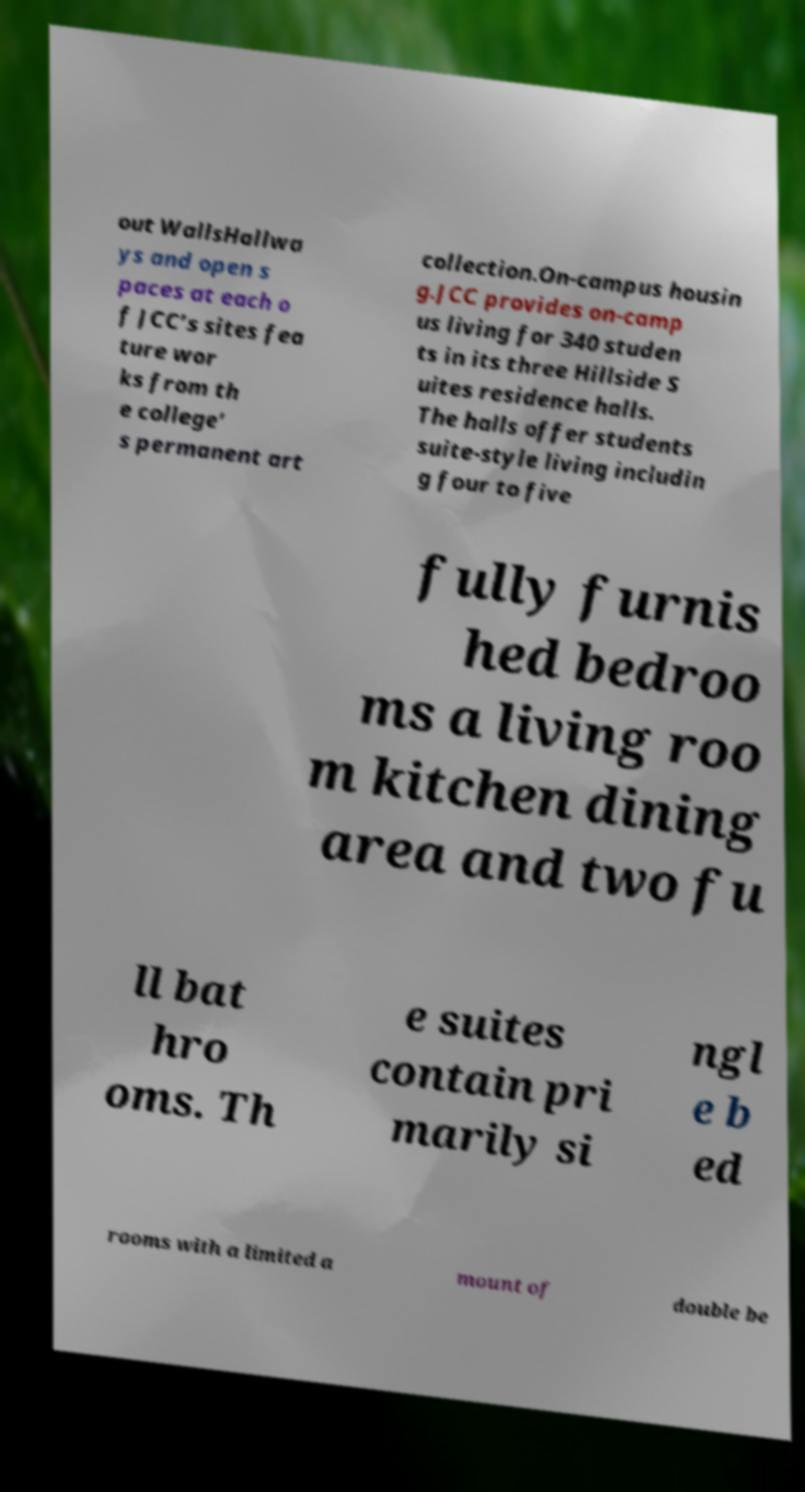Please identify and transcribe the text found in this image. out WallsHallwa ys and open s paces at each o f JCC’s sites fea ture wor ks from th e college’ s permanent art collection.On-campus housin g.JCC provides on-camp us living for 340 studen ts in its three Hillside S uites residence halls. The halls offer students suite-style living includin g four to five fully furnis hed bedroo ms a living roo m kitchen dining area and two fu ll bat hro oms. Th e suites contain pri marily si ngl e b ed rooms with a limited a mount of double be 